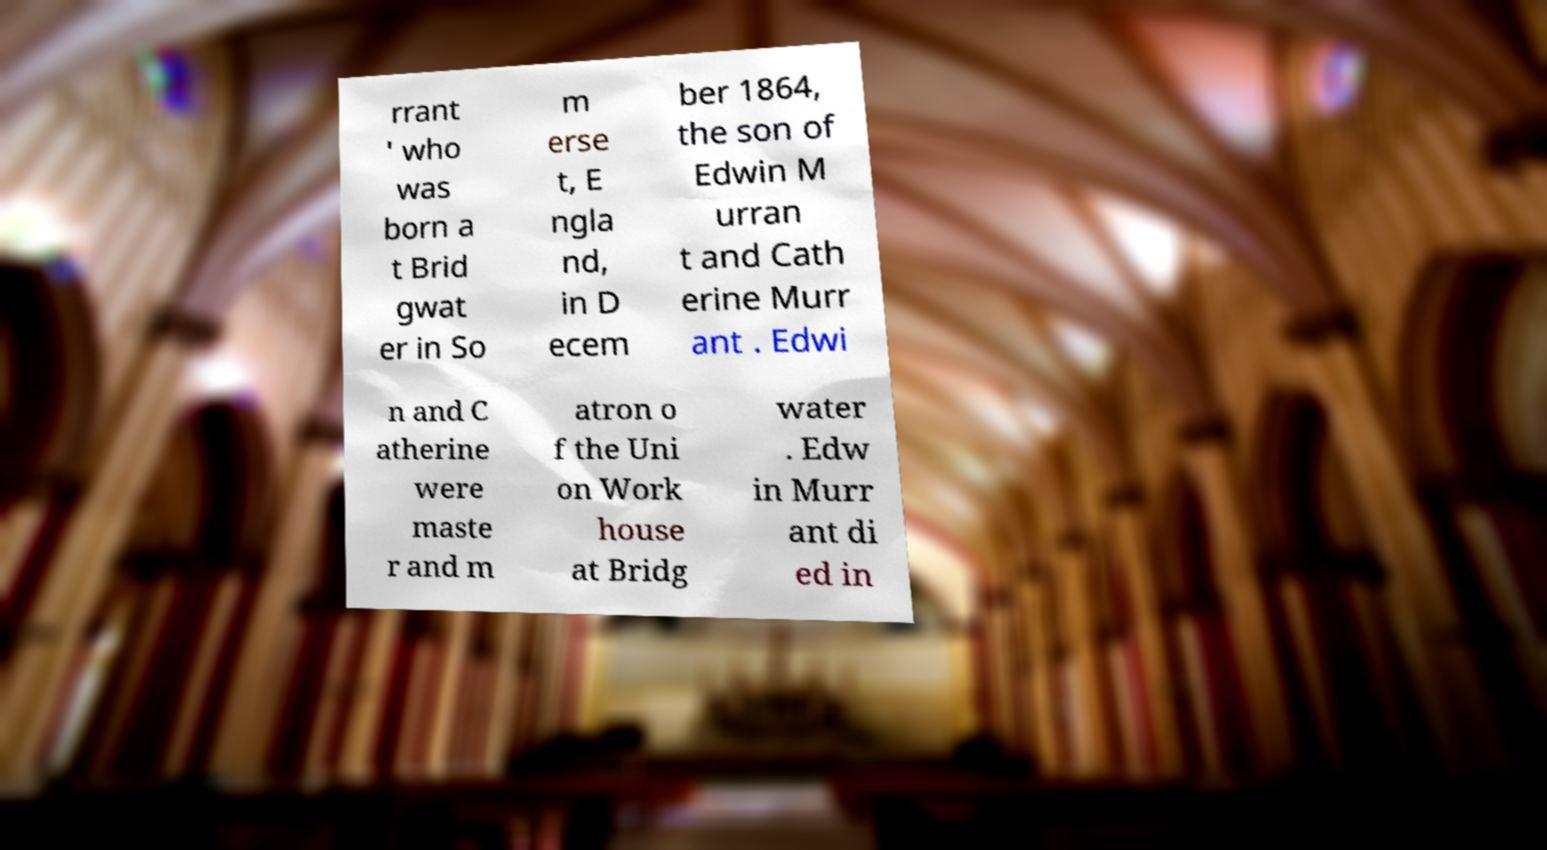Could you extract and type out the text from this image? rrant ' who was born a t Brid gwat er in So m erse t, E ngla nd, in D ecem ber 1864, the son of Edwin M urran t and Cath erine Murr ant . Edwi n and C atherine were maste r and m atron o f the Uni on Work house at Bridg water . Edw in Murr ant di ed in 